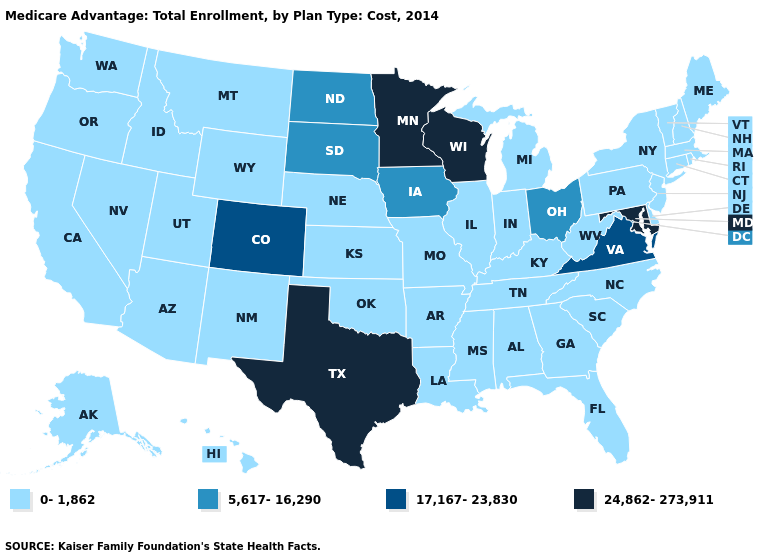What is the lowest value in states that border Alabama?
Keep it brief. 0-1,862. What is the value of Maine?
Keep it brief. 0-1,862. Which states hav the highest value in the West?
Short answer required. Colorado. What is the value of Alabama?
Keep it brief. 0-1,862. Does Connecticut have the highest value in the USA?
Keep it brief. No. Does Nebraska have the same value as Rhode Island?
Answer briefly. Yes. Name the states that have a value in the range 5,617-16,290?
Short answer required. Iowa, North Dakota, Ohio, South Dakota. Does Kansas have a lower value than Massachusetts?
Be succinct. No. What is the value of Wyoming?
Short answer required. 0-1,862. Among the states that border Rhode Island , which have the lowest value?
Keep it brief. Connecticut, Massachusetts. What is the highest value in the USA?
Concise answer only. 24,862-273,911. Which states have the highest value in the USA?
Keep it brief. Maryland, Minnesota, Texas, Wisconsin. What is the highest value in the MidWest ?
Give a very brief answer. 24,862-273,911. Does Arkansas have the highest value in the South?
Short answer required. No. Name the states that have a value in the range 17,167-23,830?
Concise answer only. Colorado, Virginia. 